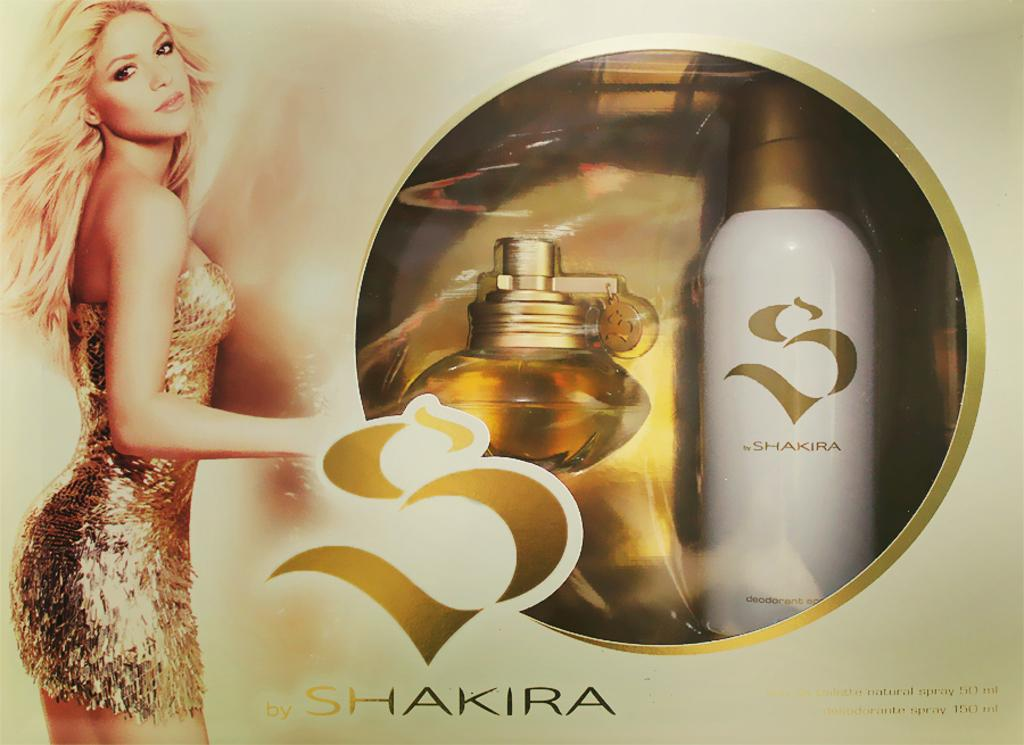<image>
Share a concise interpretation of the image provided. A fragrance is packaged in a box and labeled with SHAKIRA. 